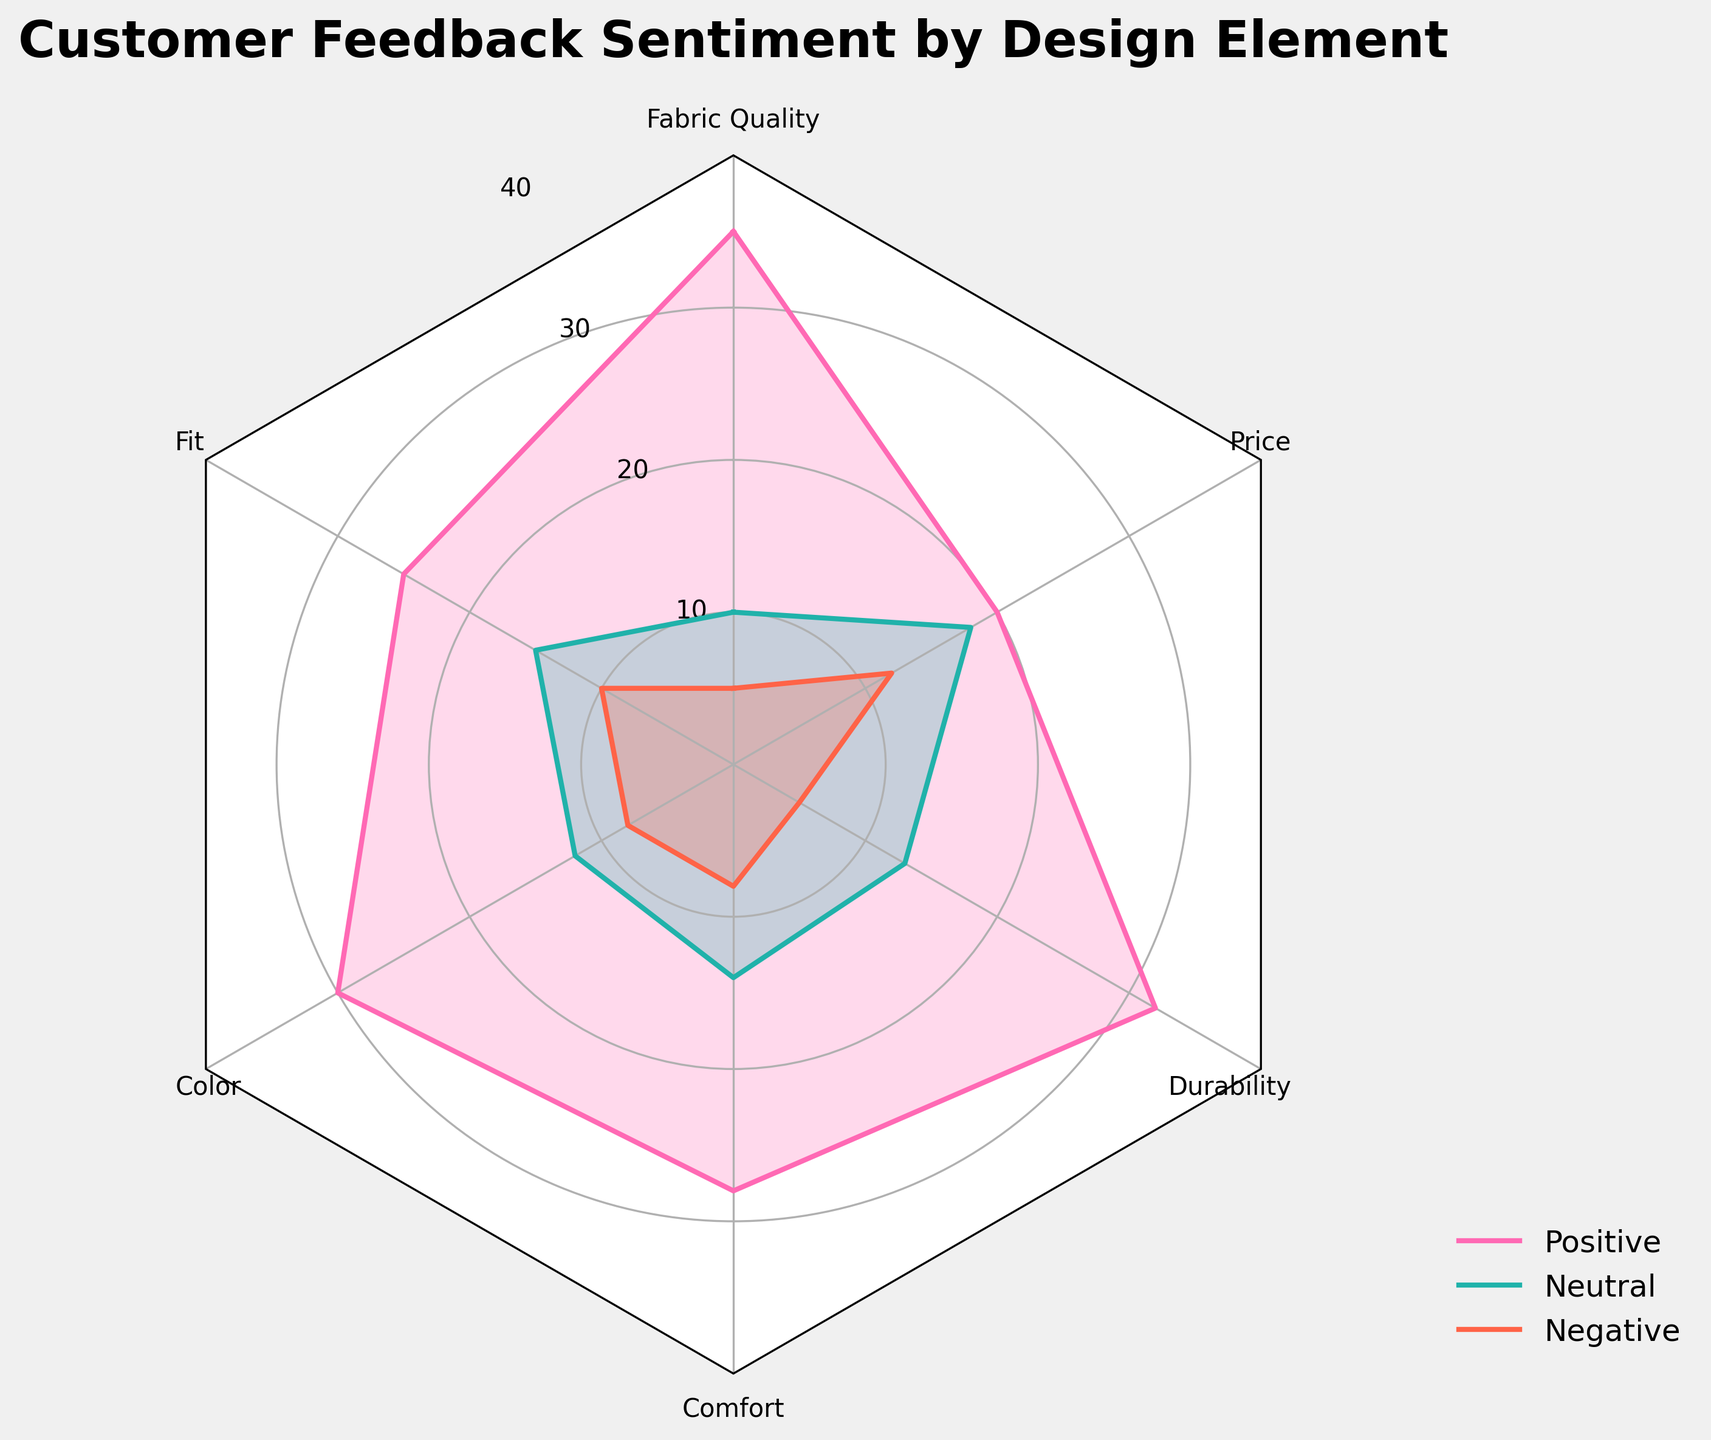What design element has the highest number of positive reviews? By looking at the radar chart, identify the element with the longest spike in the positive sentiment axis. "Fabric Quality" has the highest number of positive reviews at 35.
Answer: Fabric Quality Which sentiment category has the highest value for Price? Locate the Price data point on the radar chart and compare the lengths of the spikes for all three sentiment categories in that section. The Neutral sentiment has the highest value for Price with 18 reviews.
Answer: Neutral How many total reviews (positive, neutral, and negative) are there for Comfort? Sum the values for Comfort under all three sentiment categories. The total is 28 (Positive) + 14 (Neutral) + 8 (Negative) = 50 reviews.
Answer: 50 Which design element has the lowest number of negative reviews? Identify the region with the shortest spike in the negative sentiment axis among all design elements. "Fabric Quality" and "Durability" both have the lowest number of negative reviews at 5.
Answer: Fabric Quality, Durability What is the average number of positive reviews across all design elements? Sum the positive reviews for all design elements and divide by the number of elements. The sum is 35 + 25 + 30 + 28 + 32 + 20 = 170. The average is 170 / 6 ≈ 28.33.
Answer: 28.33 Which element shows the largest difference between positive and negative reviews? Calculate the difference between positive and negative reviews for each element and find the maximum value. Fabric Quality: 35 - 5 = 30, Fit: 25 - 10 = 15, Color: 30 - 8 = 22, Comfort: 28 - 8 = 20, Durability: 32 - 5 = 27, Price: 20 - 12 = 8. Fabric Quality has the largest difference at 30.
Answer: Fabric Quality How does the number of neutral reviews for Color compare to the neutral reviews for Fit? Compare the lengths of the spikes in the neutral sentiment axis for Color and Fit. Color has 12 Neutral reviews and Fit has 15 Neutral reviews. Fit has 3 more neutral reviews than Color.
Answer: Fit has 3 more Which design element has the highest overall sentiment (positive + neutral + negative)? Calculate the sum of positive, neutral, and negative reviews for each design element and find the maximum value. Fabric Quality: 50, Fit: 50, Color: 50, Comfort: 50, Durability: 50, Price: 50. All elements have the same overall sentiment of 50.
Answer: All elements equal at 50 Is the sentiment for Durability more positive or more neutral? Compare the lengths of the spikes for positive and neutral sentiment for Durability. Positive for Durability is 32, while neutral is 13. Durability has more positive sentiment.
Answer: Positive Which element is closest to having an equal distribution of positive, neutral, and negative reviews? Compare the spikes for each element to see which ones are closest in length for all three sentiment categories. Price is closest with values of 20 (Positive), 18 (Neutral), and 12 (Negative).
Answer: Price 